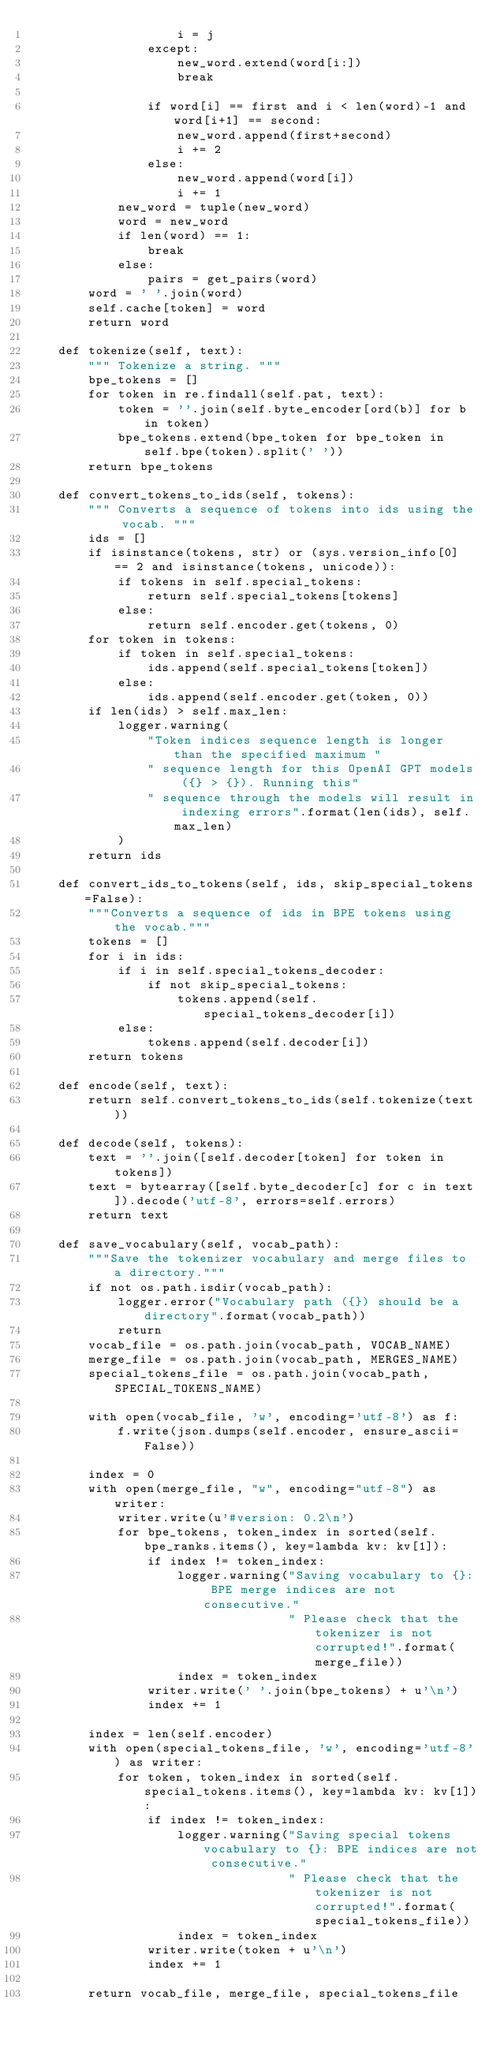<code> <loc_0><loc_0><loc_500><loc_500><_Python_>                    i = j
                except:
                    new_word.extend(word[i:])
                    break

                if word[i] == first and i < len(word)-1 and word[i+1] == second:
                    new_word.append(first+second)
                    i += 2
                else:
                    new_word.append(word[i])
                    i += 1
            new_word = tuple(new_word)
            word = new_word
            if len(word) == 1:
                break
            else:
                pairs = get_pairs(word)
        word = ' '.join(word)
        self.cache[token] = word
        return word

    def tokenize(self, text):
        """ Tokenize a string. """
        bpe_tokens = []
        for token in re.findall(self.pat, text):
            token = ''.join(self.byte_encoder[ord(b)] for b in token)
            bpe_tokens.extend(bpe_token for bpe_token in self.bpe(token).split(' '))
        return bpe_tokens

    def convert_tokens_to_ids(self, tokens):
        """ Converts a sequence of tokens into ids using the vocab. """
        ids = []
        if isinstance(tokens, str) or (sys.version_info[0] == 2 and isinstance(tokens, unicode)):
            if tokens in self.special_tokens:
                return self.special_tokens[tokens]
            else:
                return self.encoder.get(tokens, 0)
        for token in tokens:
            if token in self.special_tokens:
                ids.append(self.special_tokens[token])
            else:
                ids.append(self.encoder.get(token, 0))
        if len(ids) > self.max_len:
            logger.warning(
                "Token indices sequence length is longer than the specified maximum "
                " sequence length for this OpenAI GPT models ({} > {}). Running this"
                " sequence through the models will result in indexing errors".format(len(ids), self.max_len)
            )
        return ids

    def convert_ids_to_tokens(self, ids, skip_special_tokens=False):
        """Converts a sequence of ids in BPE tokens using the vocab."""
        tokens = []
        for i in ids:
            if i in self.special_tokens_decoder:
                if not skip_special_tokens:
                    tokens.append(self.special_tokens_decoder[i])
            else:
                tokens.append(self.decoder[i])
        return tokens

    def encode(self, text):
        return self.convert_tokens_to_ids(self.tokenize(text))

    def decode(self, tokens):
        text = ''.join([self.decoder[token] for token in tokens])
        text = bytearray([self.byte_decoder[c] for c in text]).decode('utf-8', errors=self.errors)
        return text

    def save_vocabulary(self, vocab_path):
        """Save the tokenizer vocabulary and merge files to a directory."""
        if not os.path.isdir(vocab_path):
            logger.error("Vocabulary path ({}) should be a directory".format(vocab_path))
            return
        vocab_file = os.path.join(vocab_path, VOCAB_NAME)
        merge_file = os.path.join(vocab_path, MERGES_NAME)
        special_tokens_file = os.path.join(vocab_path, SPECIAL_TOKENS_NAME)

        with open(vocab_file, 'w', encoding='utf-8') as f:
            f.write(json.dumps(self.encoder, ensure_ascii=False))

        index = 0
        with open(merge_file, "w", encoding="utf-8") as writer:
            writer.write(u'#version: 0.2\n')
            for bpe_tokens, token_index in sorted(self.bpe_ranks.items(), key=lambda kv: kv[1]):
                if index != token_index:
                    logger.warning("Saving vocabulary to {}: BPE merge indices are not consecutive."
                                   " Please check that the tokenizer is not corrupted!".format(merge_file))
                    index = token_index
                writer.write(' '.join(bpe_tokens) + u'\n')
                index += 1

        index = len(self.encoder)
        with open(special_tokens_file, 'w', encoding='utf-8') as writer:
            for token, token_index in sorted(self.special_tokens.items(), key=lambda kv: kv[1]):
                if index != token_index:
                    logger.warning("Saving special tokens vocabulary to {}: BPE indices are not consecutive."
                                   " Please check that the tokenizer is not corrupted!".format(special_tokens_file))
                    index = token_index
                writer.write(token + u'\n')
                index += 1

        return vocab_file, merge_file, special_tokens_file
</code> 